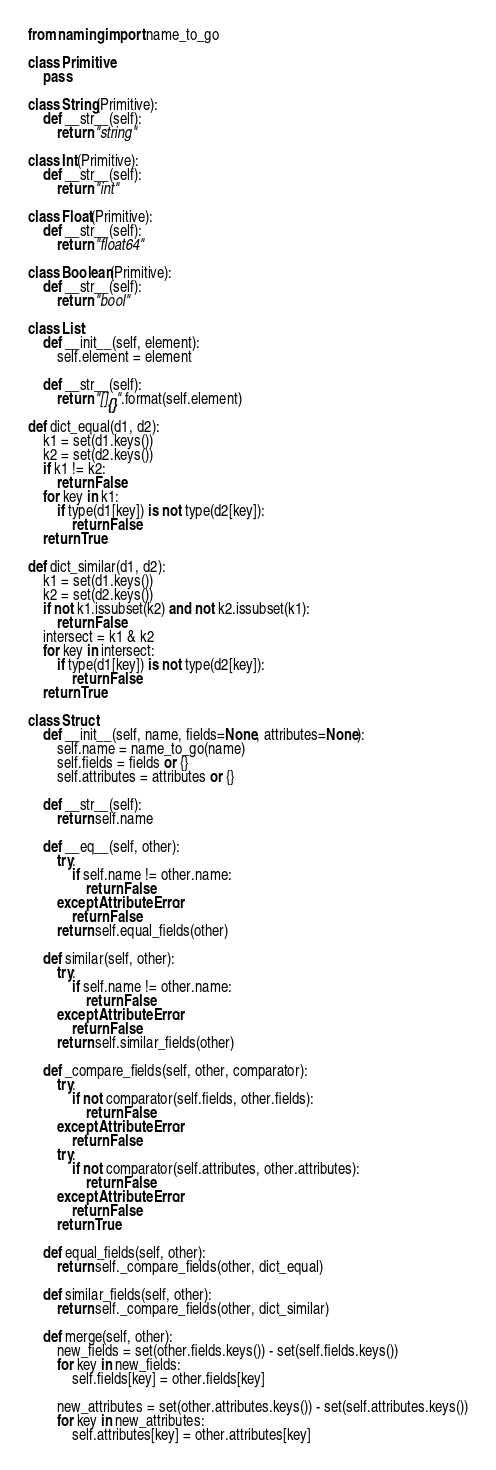Convert code to text. <code><loc_0><loc_0><loc_500><loc_500><_Python_>from naming import name_to_go

class Primitive:
    pass

class String(Primitive):
    def __str__(self):
        return "string"

class Int(Primitive):
    def __str__(self):
        return "int"

class Float(Primitive):
    def __str__(self):
        return "float64"

class Boolean(Primitive):
    def __str__(self):
        return "bool"

class List:
    def __init__(self, element):
        self.element = element

    def __str__(self):
        return "[]{}".format(self.element)

def dict_equal(d1, d2):
    k1 = set(d1.keys())
    k2 = set(d2.keys())
    if k1 != k2:
        return False
    for key in k1:
        if type(d1[key]) is not type(d2[key]):
            return False
    return True

def dict_similar(d1, d2):
    k1 = set(d1.keys())
    k2 = set(d2.keys())
    if not k1.issubset(k2) and not k2.issubset(k1):
        return False
    intersect = k1 & k2
    for key in intersect:
        if type(d1[key]) is not type(d2[key]):
            return False
    return True

class Struct:
    def __init__(self, name, fields=None, attributes=None):
        self.name = name_to_go(name)
        self.fields = fields or {}
        self.attributes = attributes or {}

    def __str__(self):
        return self.name

    def __eq__(self, other):
        try:
            if self.name != other.name:
                return False
        except AttributeError:
            return False
        return self.equal_fields(other)

    def similar(self, other):
        try:
            if self.name != other.name:
                return False
        except AttributeError:
            return False
        return self.similar_fields(other)

    def _compare_fields(self, other, comparator):
        try:
            if not comparator(self.fields, other.fields):
                return False
        except AttributeError:
            return False
        try:
            if not comparator(self.attributes, other.attributes):
                return False
        except AttributeError:
            return False
        return True

    def equal_fields(self, other):
        return self._compare_fields(other, dict_equal)

    def similar_fields(self, other):
        return self._compare_fields(other, dict_similar)

    def merge(self, other):
        new_fields = set(other.fields.keys()) - set(self.fields.keys())
        for key in new_fields:
            self.fields[key] = other.fields[key]

        new_attributes = set(other.attributes.keys()) - set(self.attributes.keys())
        for key in new_attributes:
            self.attributes[key] = other.attributes[key]
</code> 